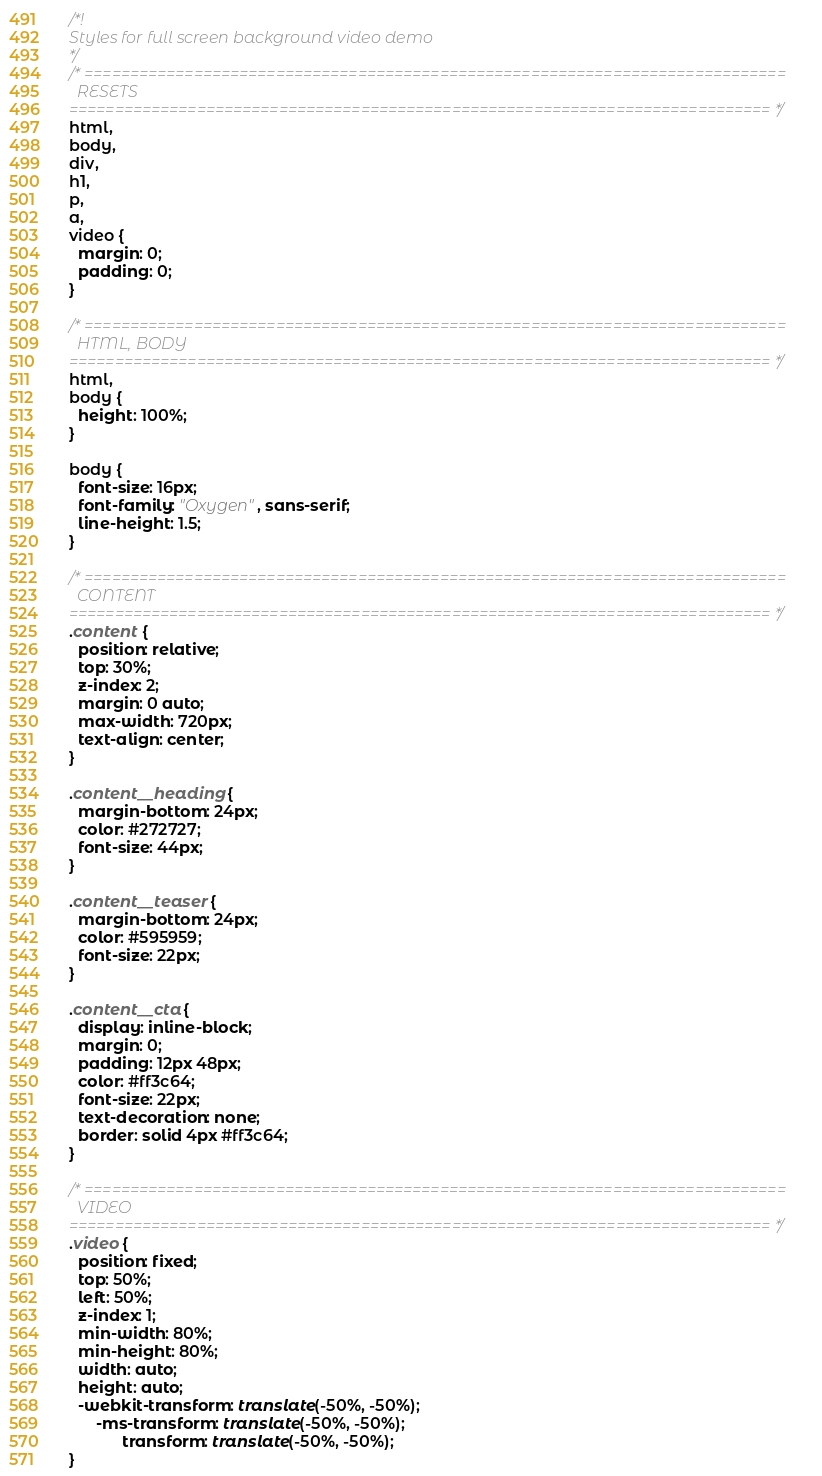<code> <loc_0><loc_0><loc_500><loc_500><_CSS_>/*!
Styles for full screen background video demo
*/
/* =============================================================================
  RESETS
============================================================================= */
html,
body,
div,
h1,
p,
a,
video {
  margin: 0;
  padding: 0;
}

/* =============================================================================
  HTML, BODY
============================================================================= */
html,
body {
  height: 100%;
}

body {
  font-size: 16px;
  font-family: "Oxygen", sans-serif;
  line-height: 1.5;
}

/* =============================================================================
  CONTENT
============================================================================= */
.content {
  position: relative;
  top: 30%;
  z-index: 2;
  margin: 0 auto;
  max-width: 720px;
  text-align: center;
}

.content__heading {
  margin-bottom: 24px;
  color: #272727;
  font-size: 44px;
}

.content__teaser {
  margin-bottom: 24px;
  color: #595959;
  font-size: 22px;
}

.content__cta {
  display: inline-block;
  margin: 0;
  padding: 12px 48px;
  color: #ff3c64;
  font-size: 22px;
  text-decoration: none;
  border: solid 4px #ff3c64;
}

/* =============================================================================
  VIDEO
============================================================================= */
.video {
  position: fixed;
  top: 50%;
  left: 50%;
  z-index: 1;
  min-width: 80%;
  min-height: 80%;
  width: auto;
  height: auto;
  -webkit-transform: translate(-50%, -50%);
      -ms-transform: translate(-50%, -50%);
            transform: translate(-50%, -50%);
}

</code> 